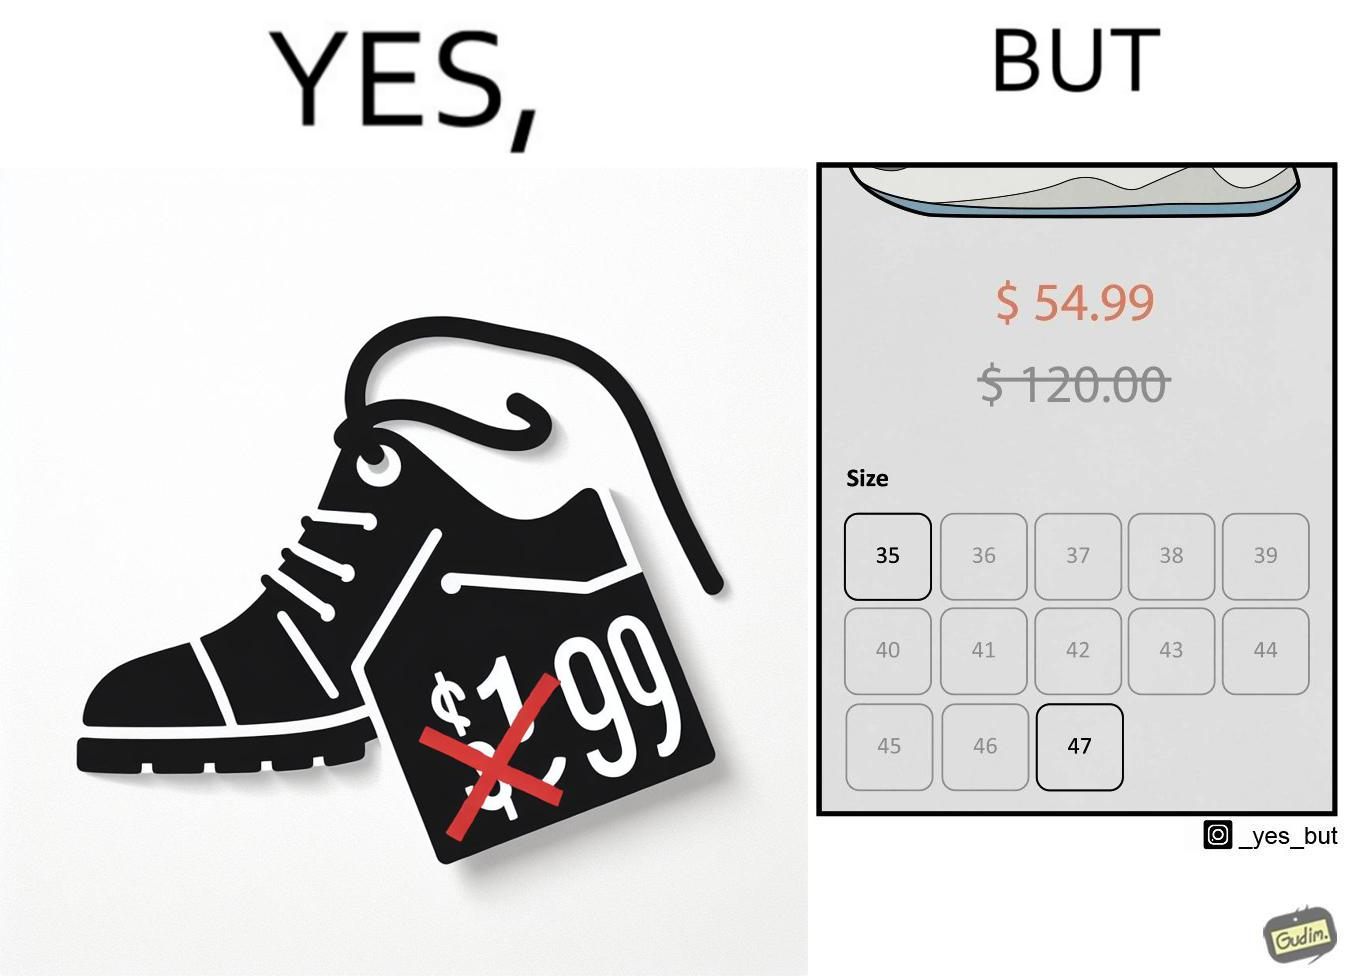Describe the satirical element in this image. The image is funny because while there is a big discount on the shoes inticing customer to buy them, the only available sizes are 35 and 47 which are the smalles and the largest meaning that a majority of the people can not buy the shoe because they won't fit. 